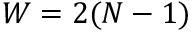Convert formula to latex. <formula><loc_0><loc_0><loc_500><loc_500>W = 2 ( N - 1 )</formula> 